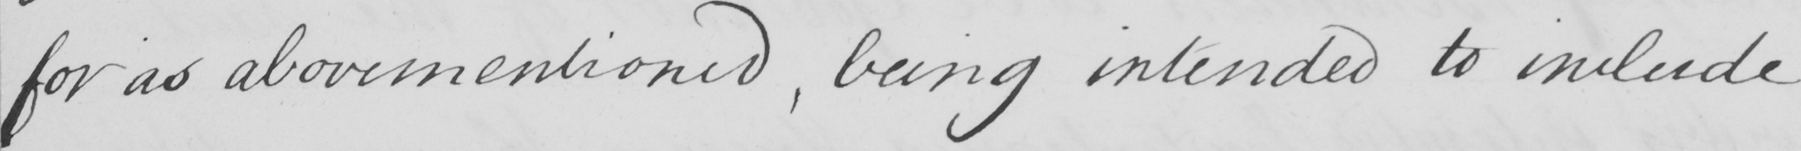What does this handwritten line say? for as abovementioned , being intended to include 